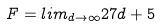Convert formula to latex. <formula><loc_0><loc_0><loc_500><loc_500>F = l i m _ { d \rightarrow \infty } 2 7 d + 5</formula> 